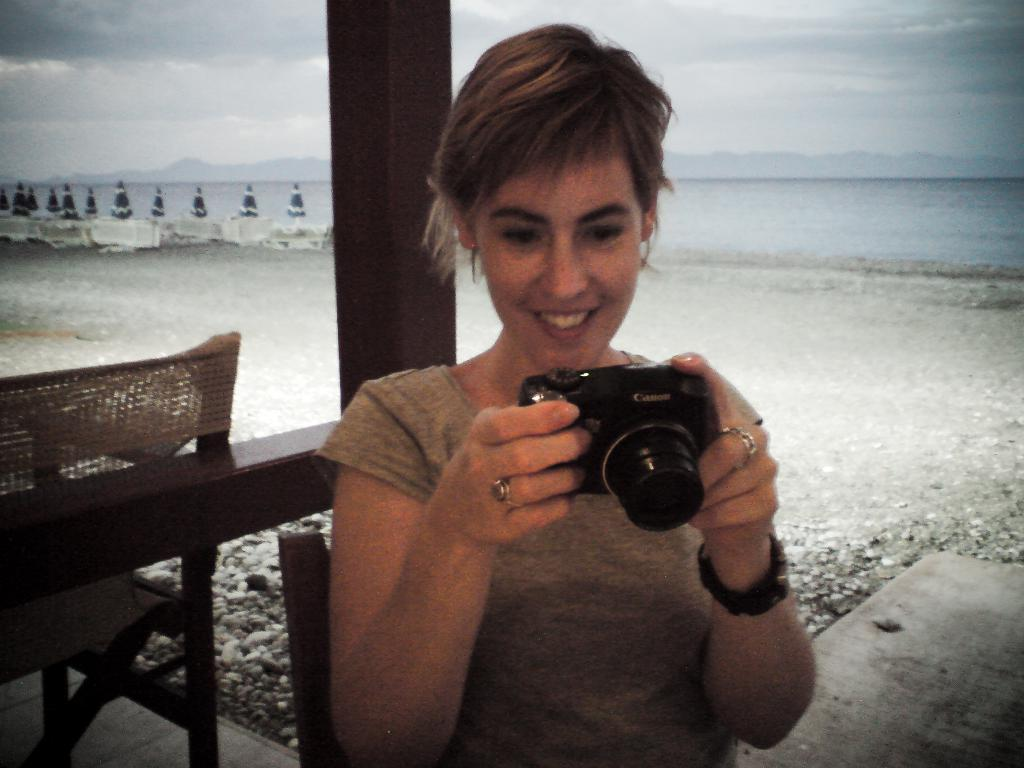Who is the main subject in the image? There is a lady in the image. What is the lady holding in the image? The lady is holding a Canon camera. Where was the image taken? The scene is clicked near the sea. What furniture can be seen in the image? There is a brown chair to the left of the image. What is the aftermath of the point made by the lady in the image? There is no indication in the image of a point being made by the lady, nor any aftermath to consider. 